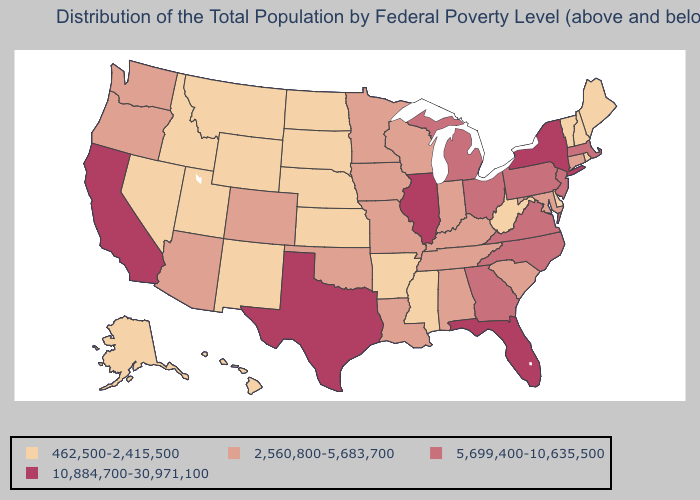Does the map have missing data?
Concise answer only. No. Name the states that have a value in the range 462,500-2,415,500?
Answer briefly. Alaska, Arkansas, Delaware, Hawaii, Idaho, Kansas, Maine, Mississippi, Montana, Nebraska, Nevada, New Hampshire, New Mexico, North Dakota, Rhode Island, South Dakota, Utah, Vermont, West Virginia, Wyoming. Which states have the highest value in the USA?
Write a very short answer. California, Florida, Illinois, New York, Texas. Does Oregon have the lowest value in the West?
Concise answer only. No. Name the states that have a value in the range 2,560,800-5,683,700?
Short answer required. Alabama, Arizona, Colorado, Connecticut, Indiana, Iowa, Kentucky, Louisiana, Maryland, Minnesota, Missouri, Oklahoma, Oregon, South Carolina, Tennessee, Washington, Wisconsin. Does New Hampshire have the highest value in the Northeast?
Give a very brief answer. No. What is the value of Utah?
Answer briefly. 462,500-2,415,500. What is the value of Nevada?
Quick response, please. 462,500-2,415,500. Name the states that have a value in the range 2,560,800-5,683,700?
Answer briefly. Alabama, Arizona, Colorado, Connecticut, Indiana, Iowa, Kentucky, Louisiana, Maryland, Minnesota, Missouri, Oklahoma, Oregon, South Carolina, Tennessee, Washington, Wisconsin. Does Texas have the highest value in the USA?
Short answer required. Yes. What is the value of New Hampshire?
Answer briefly. 462,500-2,415,500. Does Rhode Island have the same value as Arkansas?
Give a very brief answer. Yes. Among the states that border New Jersey , which have the highest value?
Write a very short answer. New York. 